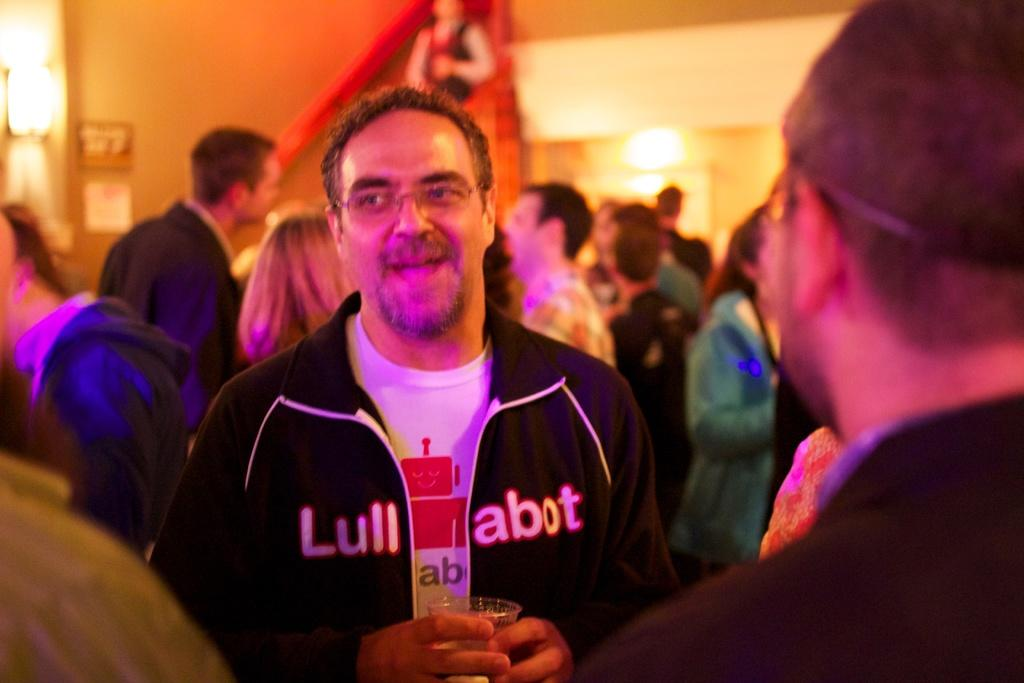Who is the main subject in the image? There is a man in the image. What can be seen in the background of the image? There are many people and a wall in the background of the image. What type of ice can be seen melting near the man in the image? There is no ice present in the image. Who is the owner of the river visible in the background of the image? There is no river visible in the image. 